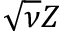Convert formula to latex. <formula><loc_0><loc_0><loc_500><loc_500>\sqrt { \nu } Z</formula> 